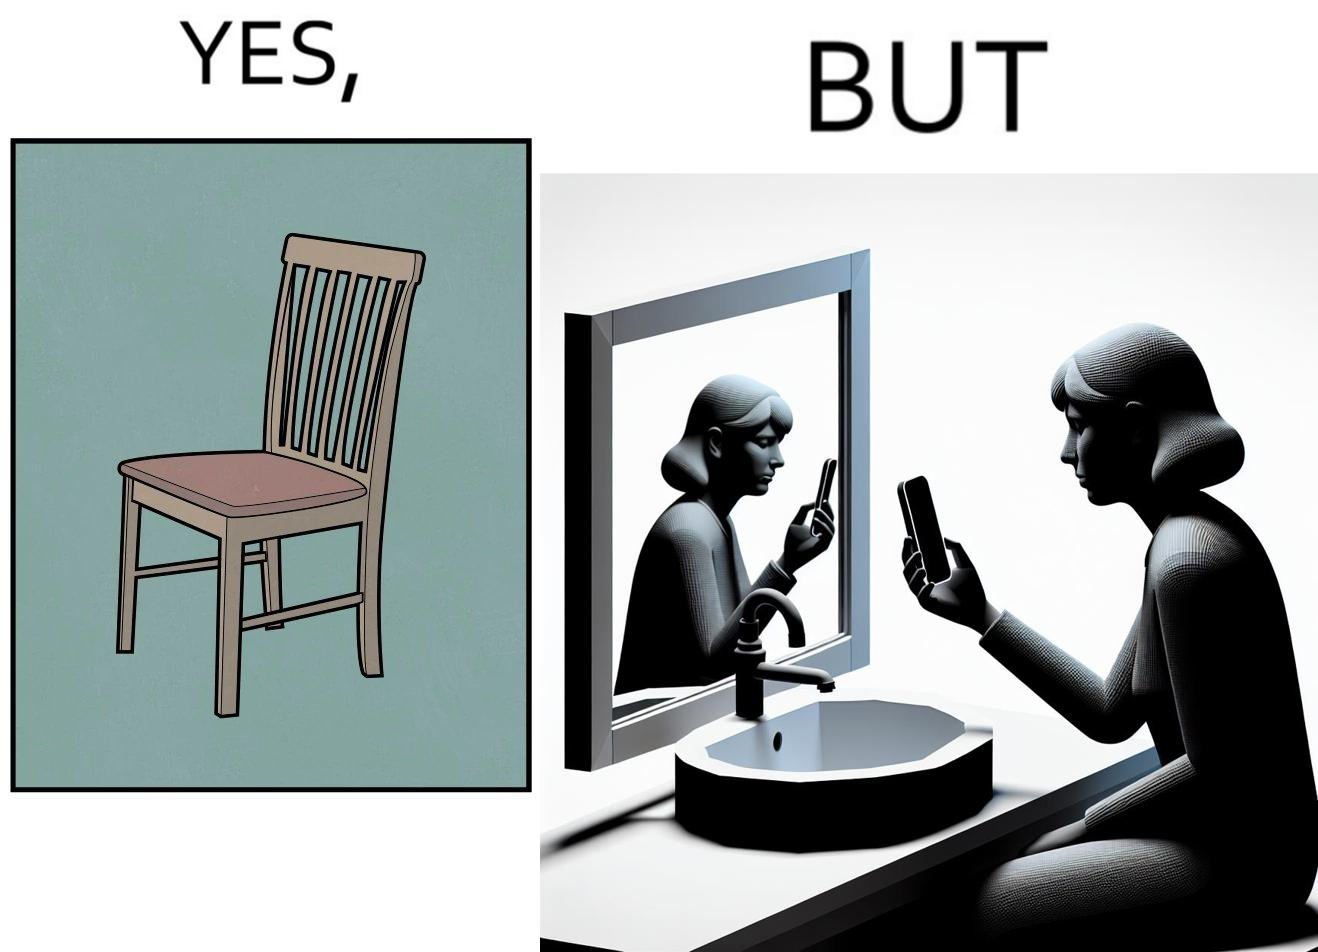Describe the content of this image. The image is ironical, as a woman is sitting by the sink taking a selfie using a mirror, while not using a chair that is actually meant for sitting. 